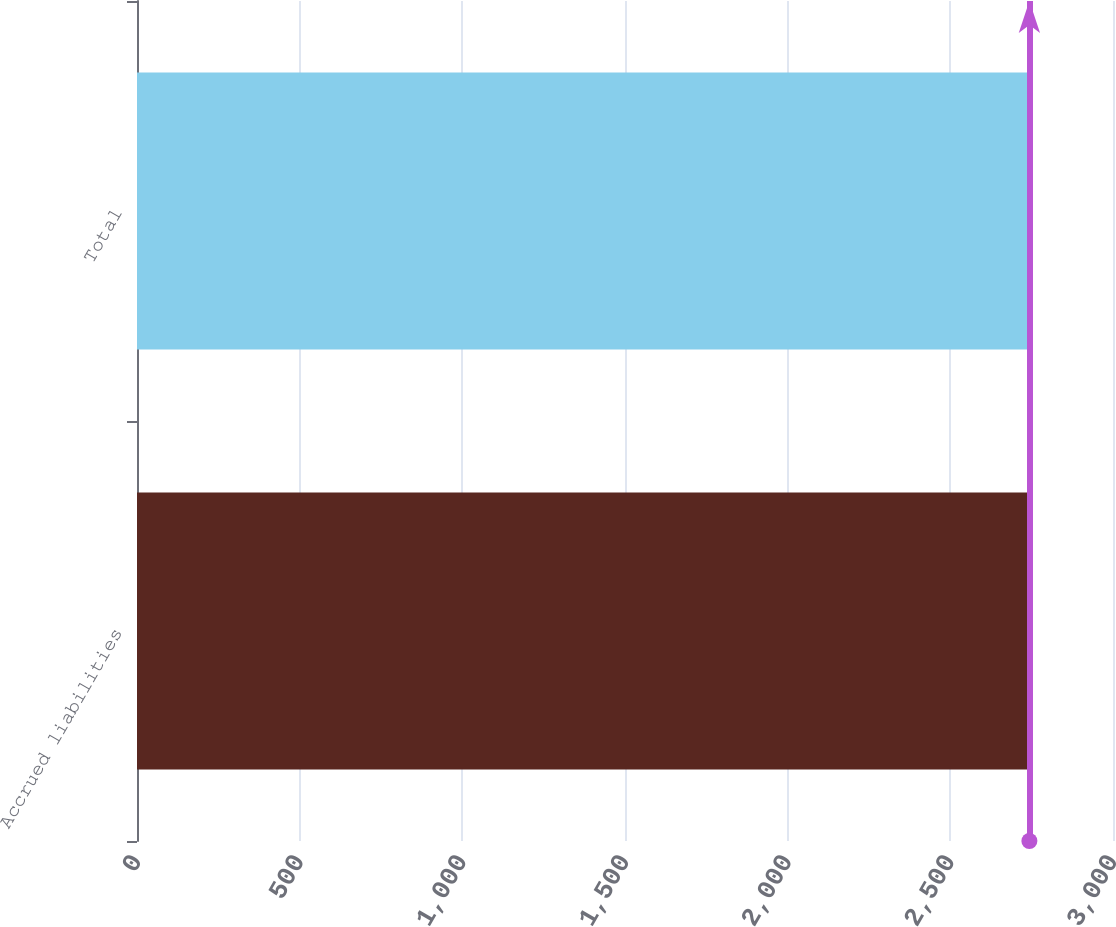Convert chart to OTSL. <chart><loc_0><loc_0><loc_500><loc_500><bar_chart><fcel>Accrued liabilities<fcel>Total<nl><fcel>2743<fcel>2743.1<nl></chart> 